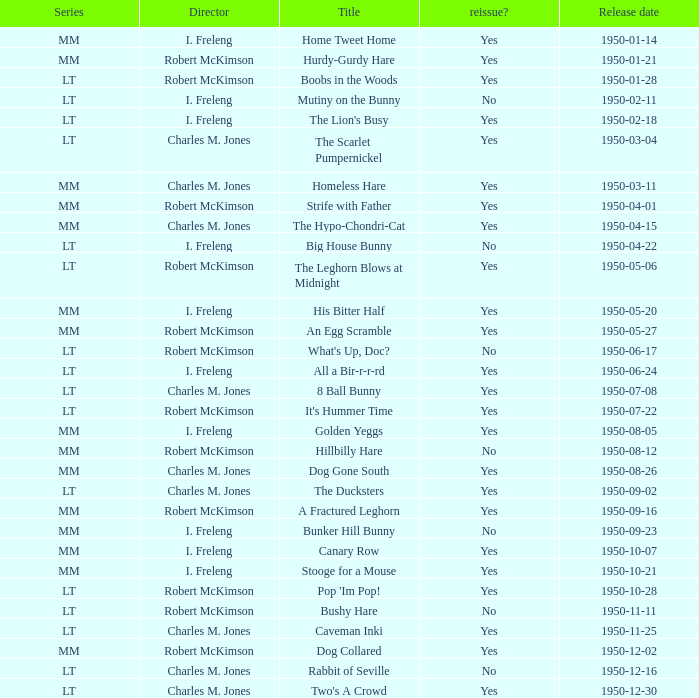Who directed An Egg Scramble? Robert McKimson. 